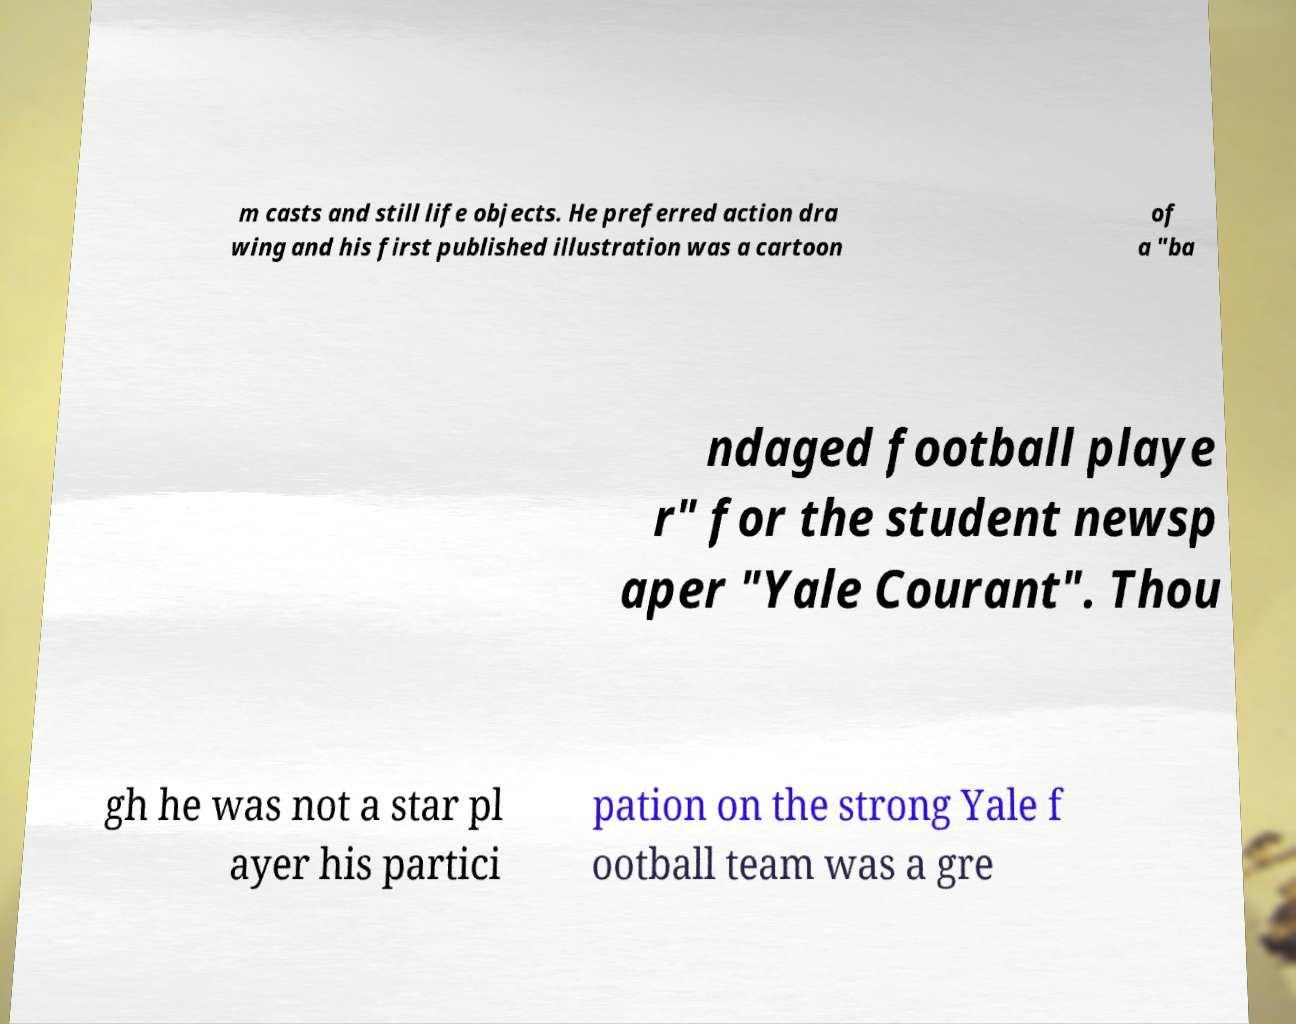Can you accurately transcribe the text from the provided image for me? m casts and still life objects. He preferred action dra wing and his first published illustration was a cartoon of a "ba ndaged football playe r" for the student newsp aper "Yale Courant". Thou gh he was not a star pl ayer his partici pation on the strong Yale f ootball team was a gre 